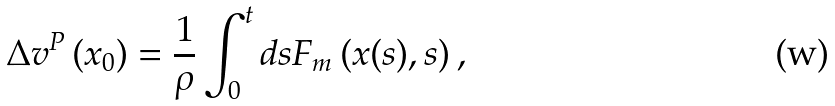<formula> <loc_0><loc_0><loc_500><loc_500>\Delta v ^ { P } \left ( x _ { 0 } \right ) = \frac { 1 } { \rho } \int _ { 0 } ^ { t } d s F _ { m } \left ( x ( s ) , s \right ) ,</formula> 